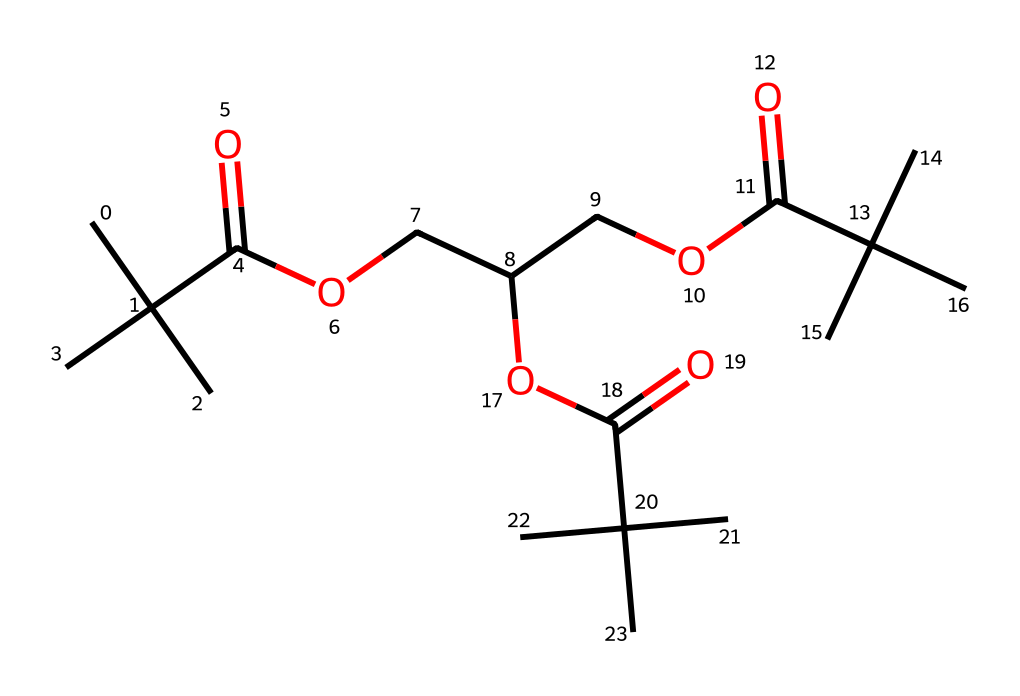what is the total number of carbon atoms in this chemical? By analyzing the provided SMILES structure, we count each 'C' that represents a carbon atom, including those in branches and functional groups. There are 15 carbon atoms in total.
Answer: 15 how many ester functional groups are present in the molecule? The SMILES representation shows several instances of the ester functional group, characterized by 'C(=O)O'. Counting these reveals there are three distinct ester linkages in the molecule.
Answer: 3 what type of polymer is represented by this structure? The presence of multiple ester groups and branching carbons indicates that this chemical likely belongs to the family of polyesters, which are commonly used in high-performance applications.
Answer: polyester what is the degree of branching observed in this polymer? Due to the presence of tertiary carbons (as seen in CC(C)(C)), which create branches off the chain, it indicates a high degree of branching, observable in the structure where multiple bulky groups are attached to a main chain.
Answer: high how does the molecular structure affect the thermal stability of the polymer? The bulky branches and ester linkages create strong intermolecular forces, which enhance thermal stability by increasing the melting point and resistance to degradation under heat compared to linear polymers.
Answer: enhanced what is the expected application of this polymer in sports equipment? Given its high performance characteristics derived from branching and ester functions, this polymer is likely used in applications requiring lightweight and strong materials, such as in composites for sports gear like racquets or sports apparel.
Answer: sports gear 